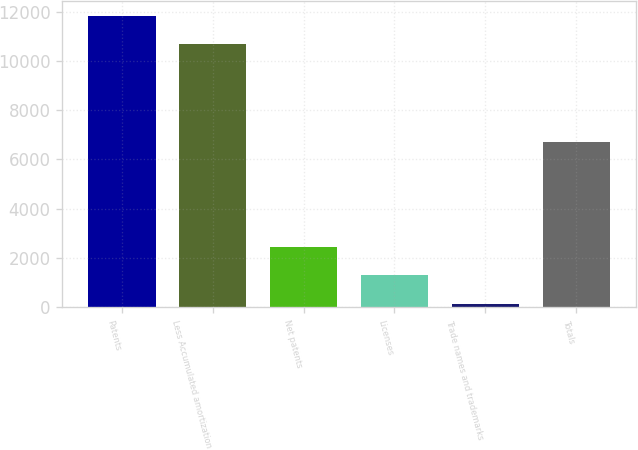Convert chart to OTSL. <chart><loc_0><loc_0><loc_500><loc_500><bar_chart><fcel>Patents<fcel>Less Accumulated amortization<fcel>Net patents<fcel>Licenses<fcel>Trade names and trademarks<fcel>Totals<nl><fcel>11838.9<fcel>10672<fcel>2464.8<fcel>1297.9<fcel>131<fcel>6709<nl></chart> 